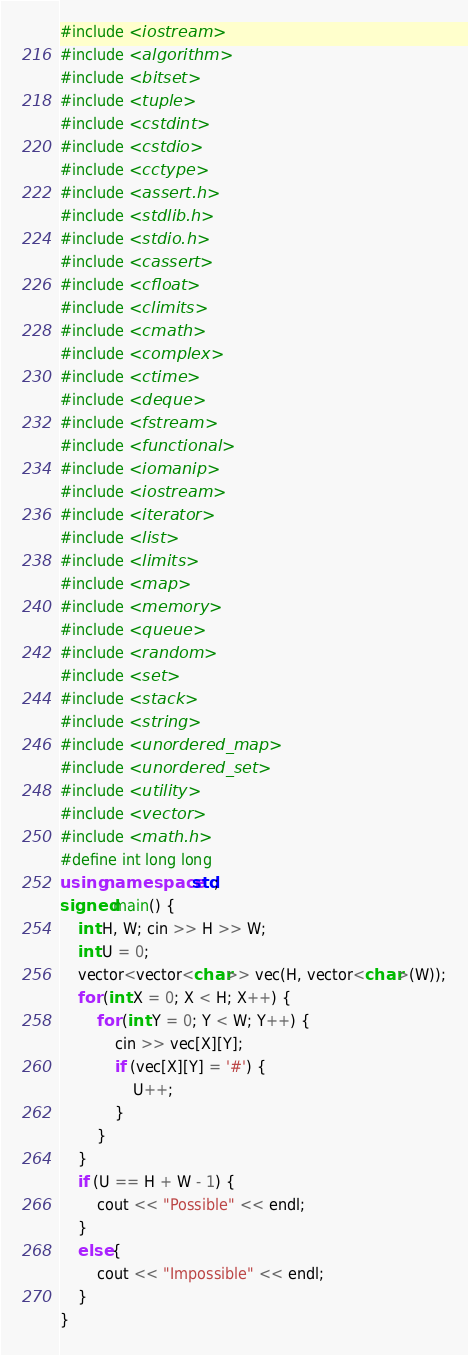Convert code to text. <code><loc_0><loc_0><loc_500><loc_500><_C++_>#include <iostream>
#include <algorithm>
#include <bitset>
#include <tuple>
#include <cstdint>
#include <cstdio>
#include <cctype>
#include <assert.h>
#include <stdlib.h>
#include <stdio.h>
#include <cassert>
#include <cfloat>
#include <climits>
#include <cmath>
#include <complex>
#include <ctime>
#include <deque>
#include <fstream>
#include <functional>
#include <iomanip>
#include <iostream>
#include <iterator>
#include <list>
#include <limits>
#include <map>
#include <memory>
#include <queue>
#include <random>
#include <set>
#include <stack>
#include <string>
#include <unordered_map>
#include <unordered_set>
#include <utility>
#include <vector>
#include <math.h>
#define int long long
using namespace std;
signed main() {
	int H, W; cin >> H >> W;
	int U = 0;
	vector<vector<char>> vec(H, vector<char>(W));
	for (int X = 0; X < H; X++) {
		for (int Y = 0; Y < W; Y++) {
			cin >> vec[X][Y];
			if (vec[X][Y] = '#') {
				U++;
			}
		}
	}
	if (U == H + W - 1) {
		cout << "Possible" << endl;
	}
	else {
		cout << "Impossible" << endl;
	}
}</code> 